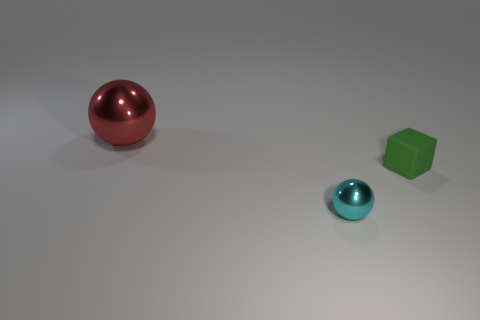What size is the green thing?
Make the answer very short. Small. There is a small cyan object; how many big balls are to the left of it?
Make the answer very short. 1. There is a ball to the right of the large red thing that is behind the green rubber object; what size is it?
Make the answer very short. Small. There is a thing to the left of the cyan metallic sphere; is its shape the same as the tiny thing behind the small cyan shiny object?
Make the answer very short. No. What is the shape of the tiny object on the right side of the sphere that is in front of the tiny green rubber thing?
Give a very brief answer. Cube. What is the size of the thing that is both left of the small block and in front of the big red shiny object?
Offer a terse response. Small. There is a tiny metal object; does it have the same shape as the metallic object that is behind the tiny green matte object?
Offer a very short reply. Yes. There is another thing that is the same shape as the large shiny thing; what size is it?
Make the answer very short. Small. Is the color of the big shiny ball the same as the shiny ball that is in front of the red sphere?
Offer a terse response. No. What number of other things are there of the same size as the red shiny ball?
Offer a very short reply. 0. 